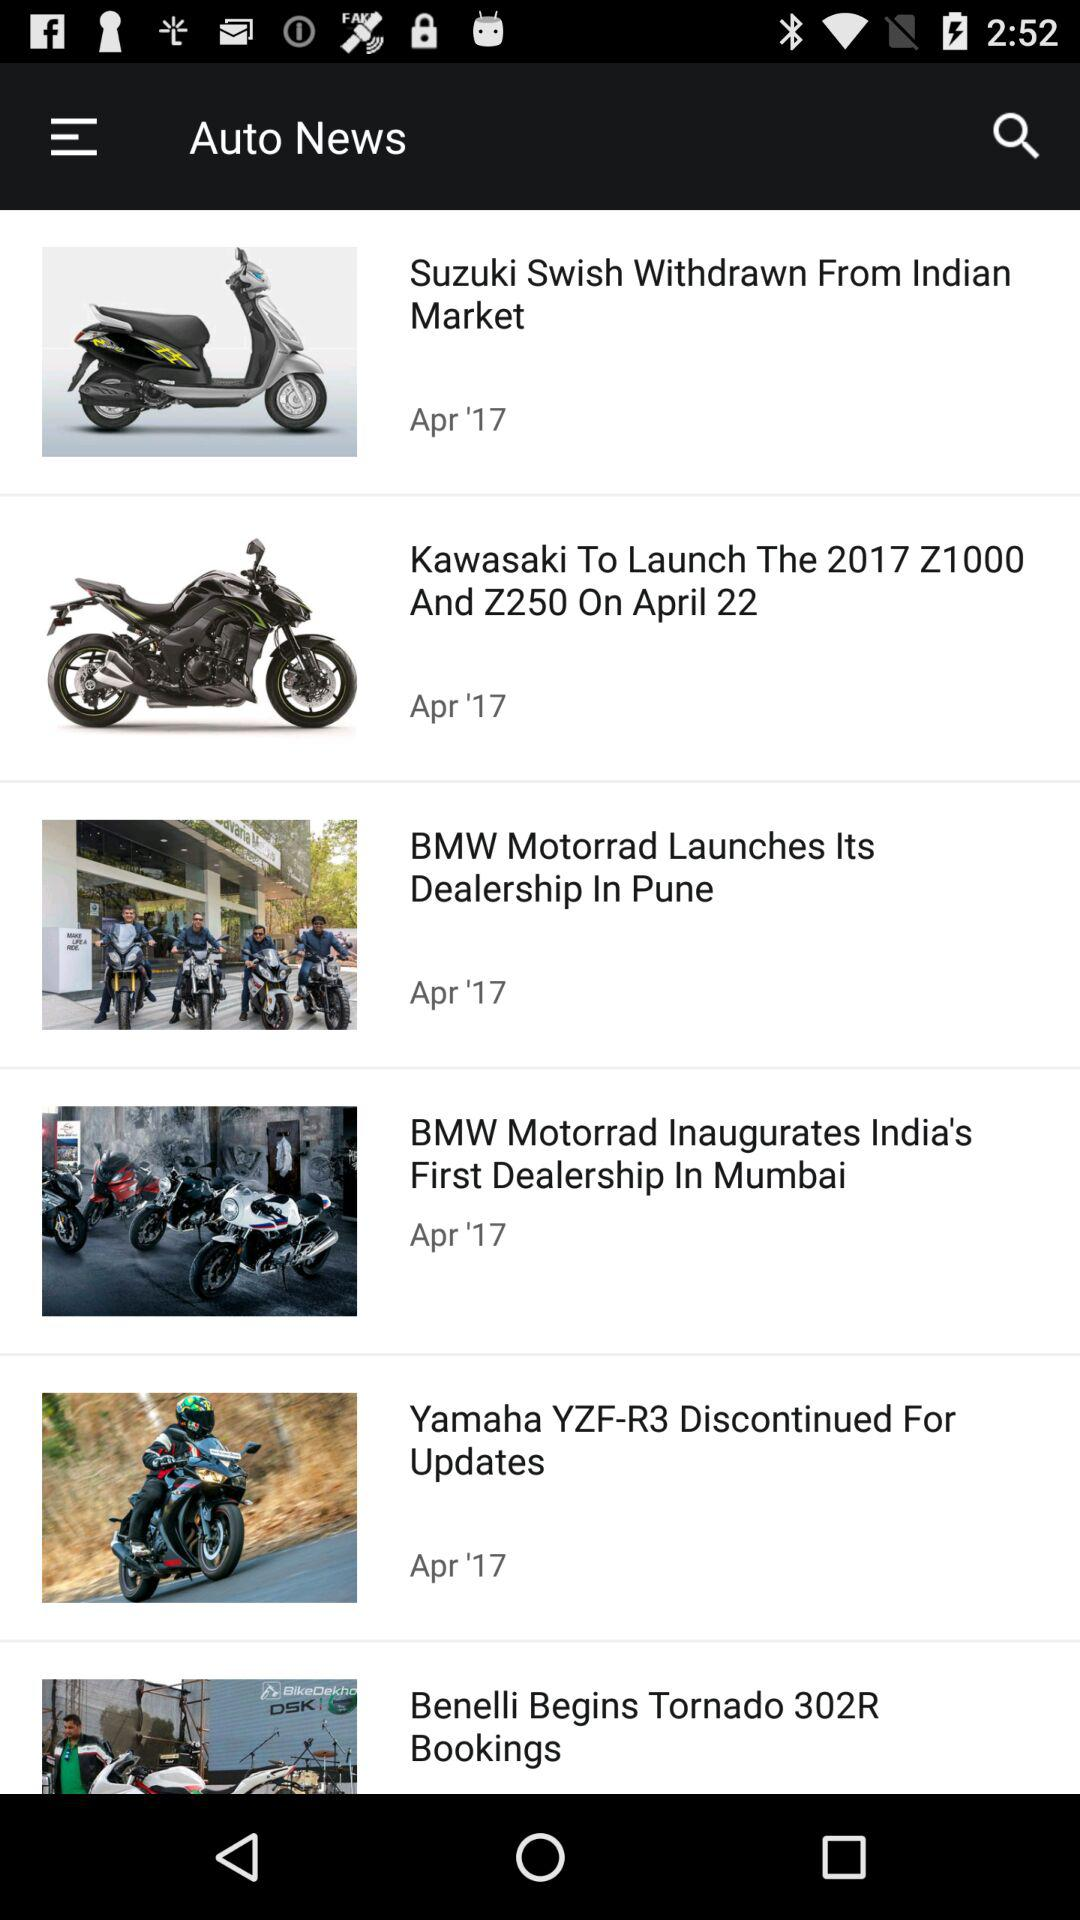How many of the articles are about BMW Motorrad?
Answer the question using a single word or phrase. 2 